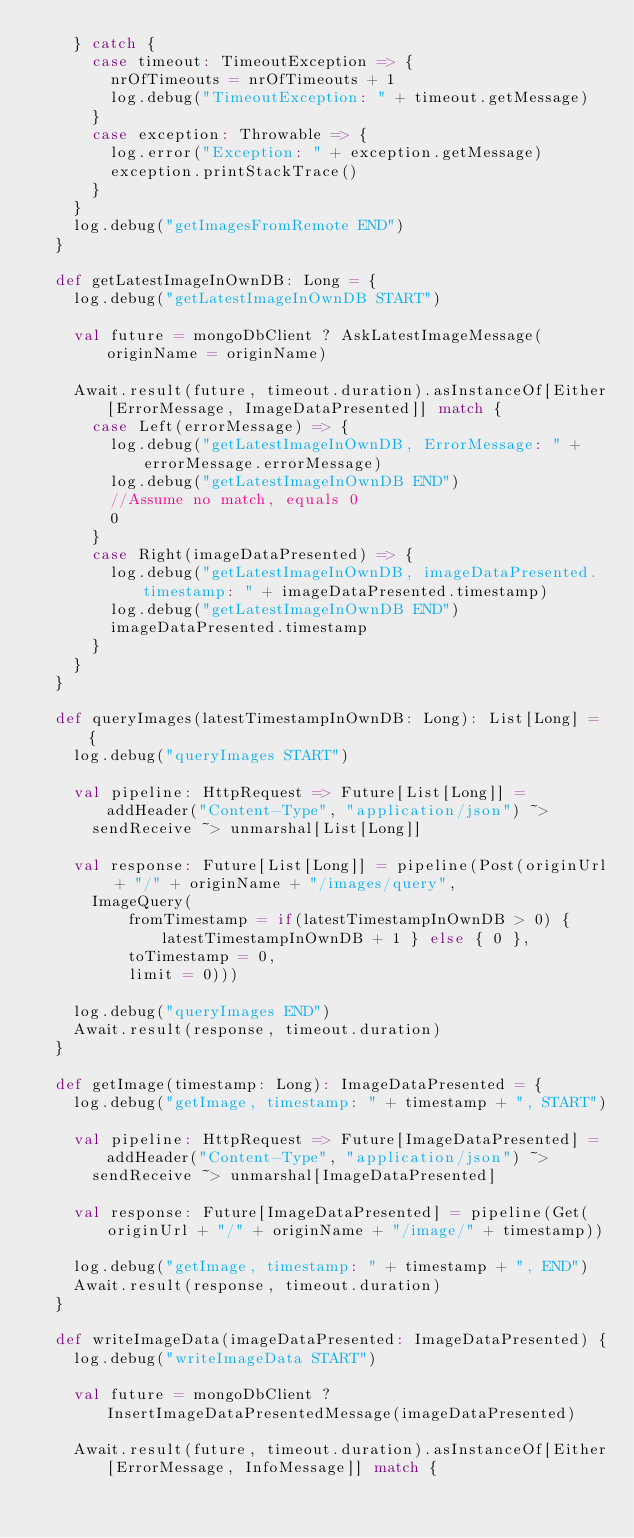Convert code to text. <code><loc_0><loc_0><loc_500><loc_500><_Scala_>    } catch {
      case timeout: TimeoutException => {
        nrOfTimeouts = nrOfTimeouts + 1
        log.debug("TimeoutException: " + timeout.getMessage)
      }
      case exception: Throwable => {
        log.error("Exception: " + exception.getMessage)
        exception.printStackTrace()
      }
    }
    log.debug("getImagesFromRemote END")
  }

  def getLatestImageInOwnDB: Long = {
    log.debug("getLatestImageInOwnDB START")

    val future = mongoDbClient ? AskLatestImageMessage(originName = originName)

    Await.result(future, timeout.duration).asInstanceOf[Either[ErrorMessage, ImageDataPresented]] match {
      case Left(errorMessage) => {
        log.debug("getLatestImageInOwnDB, ErrorMessage: " + errorMessage.errorMessage)
        log.debug("getLatestImageInOwnDB END")
        //Assume no match, equals 0
        0
      }
      case Right(imageDataPresented) => {
        log.debug("getLatestImageInOwnDB, imageDataPresented.timestamp: " + imageDataPresented.timestamp)
        log.debug("getLatestImageInOwnDB END")
        imageDataPresented.timestamp
      }
    }
  }

  def queryImages(latestTimestampInOwnDB: Long): List[Long] = {
    log.debug("queryImages START")

    val pipeline: HttpRequest => Future[List[Long]] = addHeader("Content-Type", "application/json") ~> 
      sendReceive ~> unmarshal[List[Long]]
    
    val response: Future[List[Long]] = pipeline(Post(originUrl + "/" + originName + "/images/query",
      ImageQuery(
          fromTimestamp = if(latestTimestampInOwnDB > 0) { latestTimestampInOwnDB + 1 } else { 0 }, 
          toTimestamp = 0, 
          limit = 0)))

    log.debug("queryImages END")
    Await.result(response, timeout.duration)
  }

  def getImage(timestamp: Long): ImageDataPresented = {
    log.debug("getImage, timestamp: " + timestamp + ", START")

    val pipeline: HttpRequest => Future[ImageDataPresented] = addHeader("Content-Type", "application/json") ~>
      sendReceive ~> unmarshal[ImageDataPresented]

    val response: Future[ImageDataPresented] = pipeline(Get(originUrl + "/" + originName + "/image/" + timestamp))

    log.debug("getImage, timestamp: " + timestamp + ", END")
    Await.result(response, timeout.duration)
  }

  def writeImageData(imageDataPresented: ImageDataPresented) {
    log.debug("writeImageData START")

    val future = mongoDbClient ? InsertImageDataPresentedMessage(imageDataPresented)

    Await.result(future, timeout.duration).asInstanceOf[Either[ErrorMessage, InfoMessage]] match {</code> 